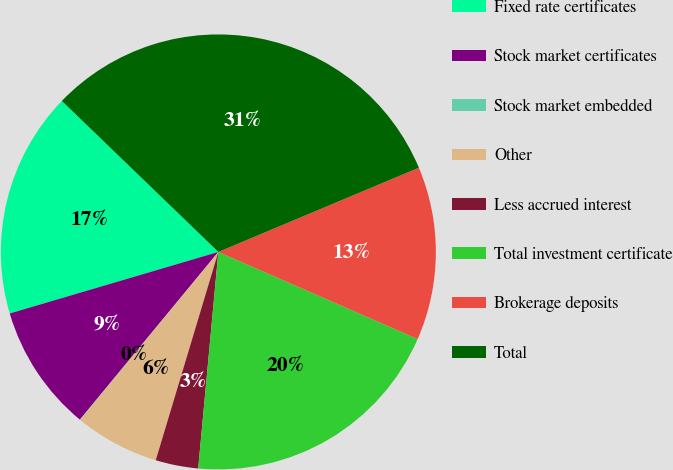<chart> <loc_0><loc_0><loc_500><loc_500><pie_chart><fcel>Fixed rate certificates<fcel>Stock market certificates<fcel>Stock market embedded<fcel>Other<fcel>Less accrued interest<fcel>Total investment certificate<fcel>Brokerage deposits<fcel>Total<nl><fcel>16.78%<fcel>9.45%<fcel>0.03%<fcel>6.31%<fcel>3.17%<fcel>19.92%<fcel>12.89%<fcel>31.46%<nl></chart> 